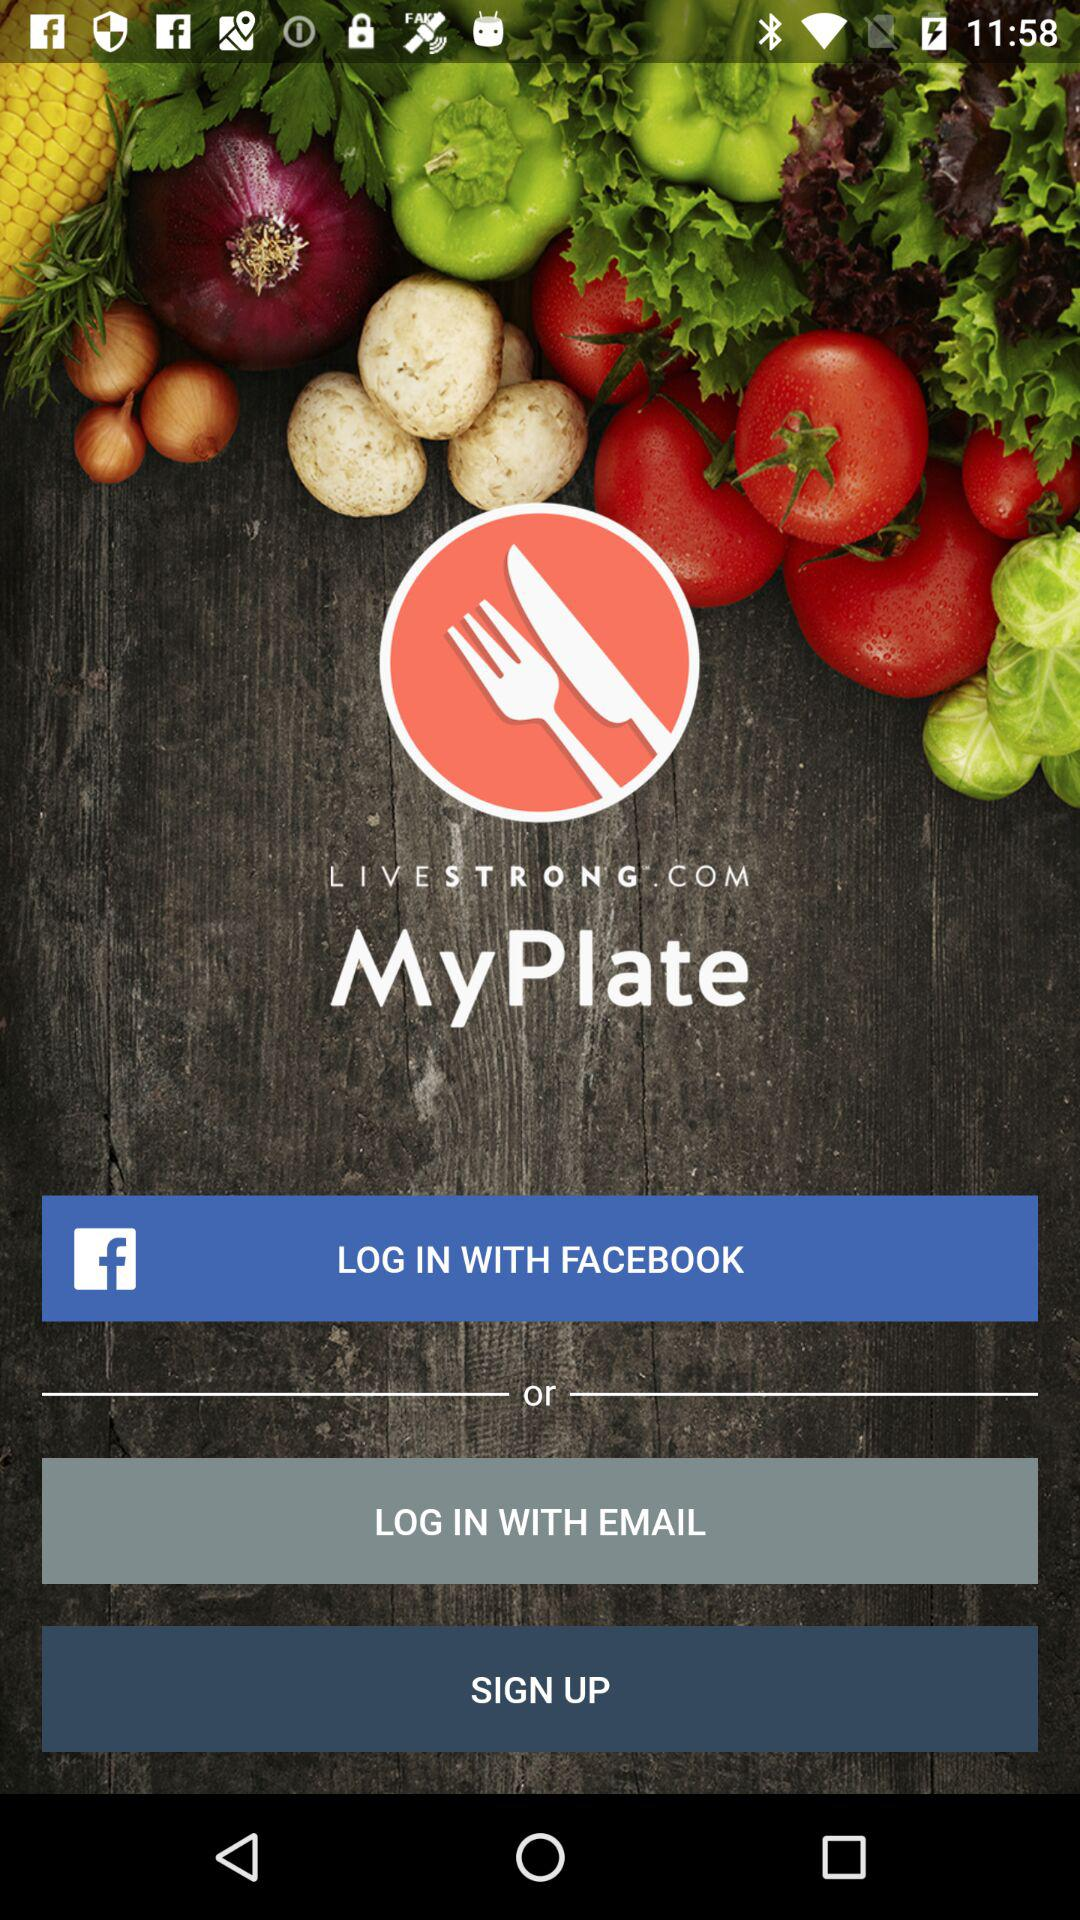Which account can I use to log in? You can use "FACEBOOK" and "EMAIL" accounts to log in. 